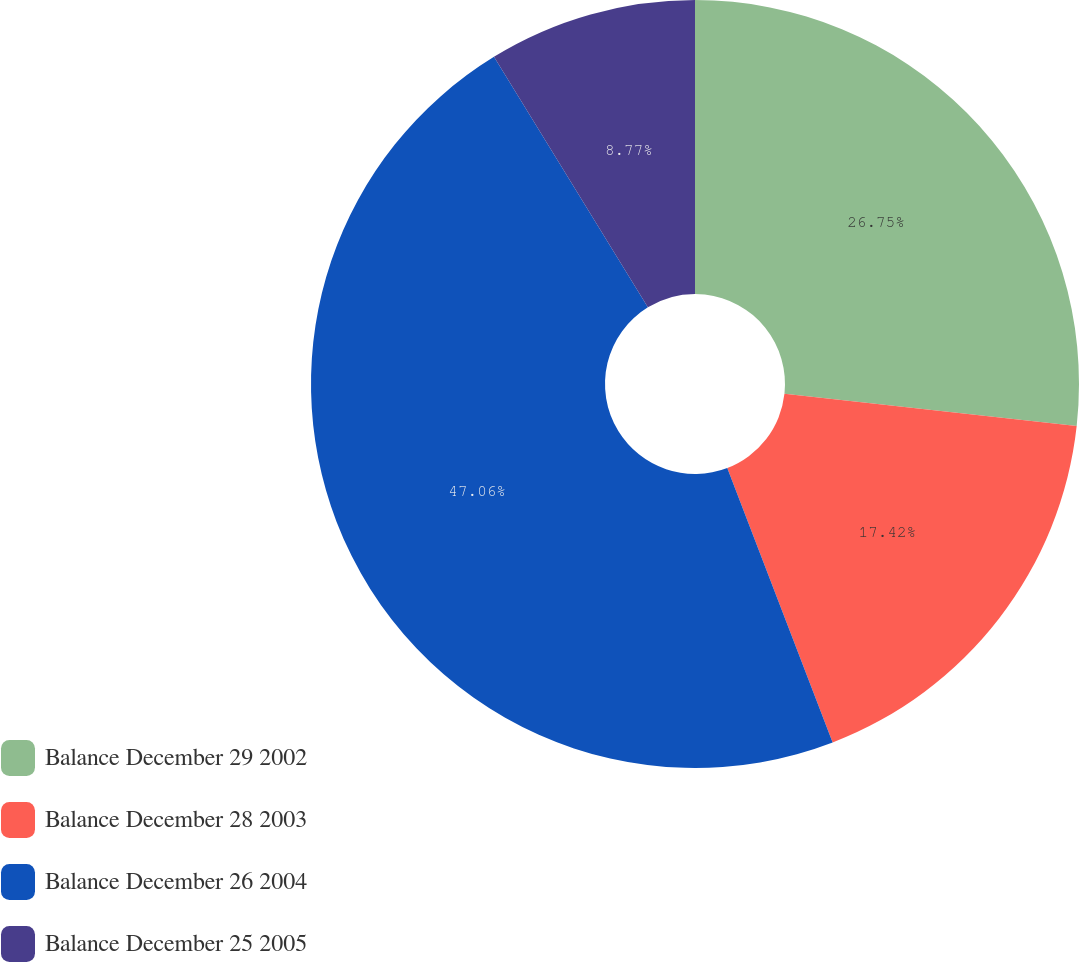Convert chart. <chart><loc_0><loc_0><loc_500><loc_500><pie_chart><fcel>Balance December 29 2002<fcel>Balance December 28 2003<fcel>Balance December 26 2004<fcel>Balance December 25 2005<nl><fcel>26.75%<fcel>17.42%<fcel>47.07%<fcel>8.77%<nl></chart> 